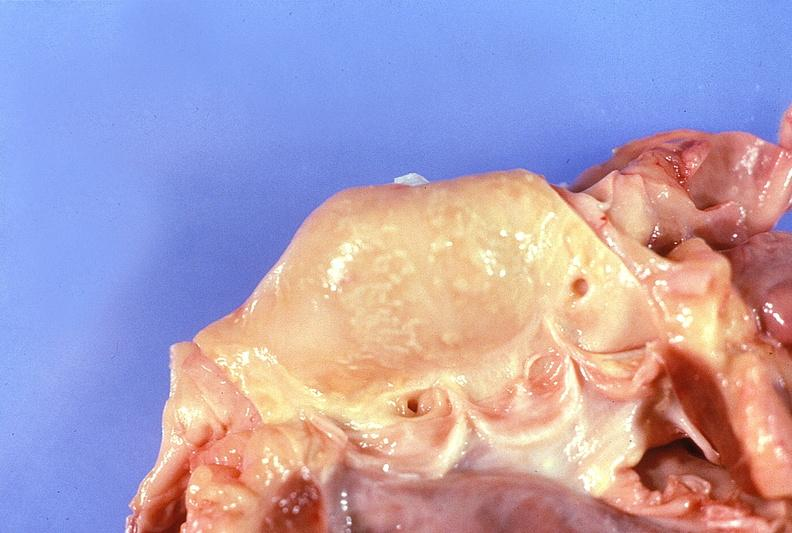s cardiovascular present?
Answer the question using a single word or phrase. Yes 